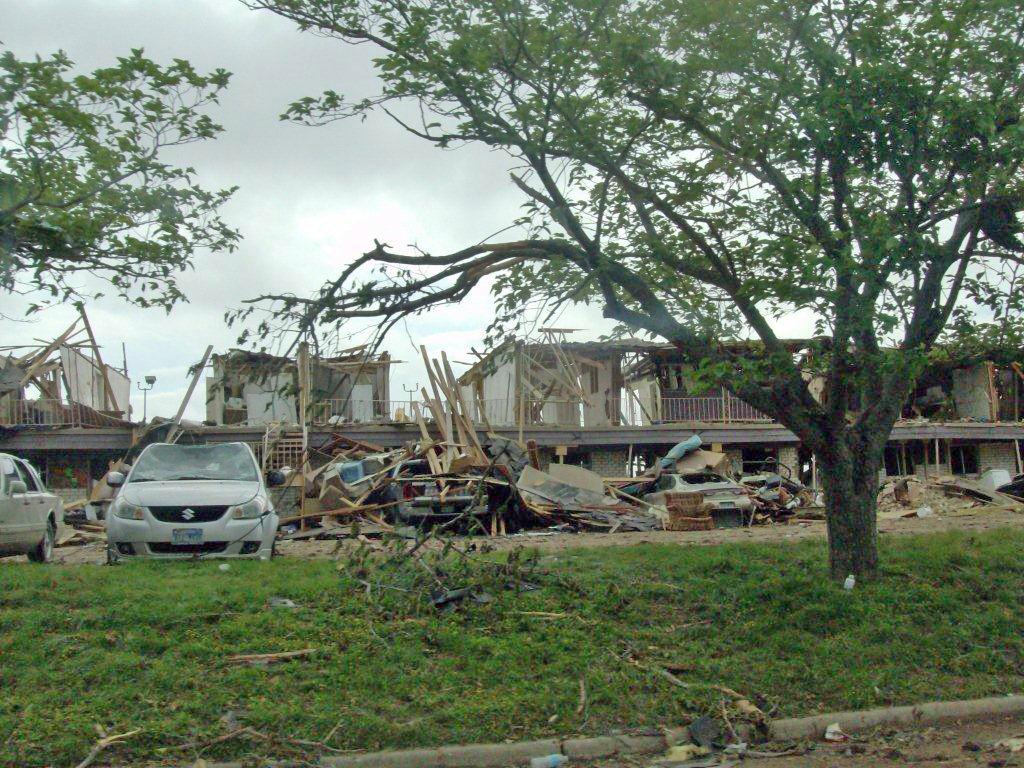What is the main subject of the image? The main subject of the image is a collapsed building. What else can be seen in the image besides the building? There are vehicles, grass, trees, and other items visible in the image. What is the condition of the sky in the image? The sky is visible in the background of the image. How many chairs are placed around the collapsed building in the image? There are no chairs present in the image. What type of reward is being given to the people in the image? There are no people or rewards depicted in the image; it features a collapsed building and other elements. 